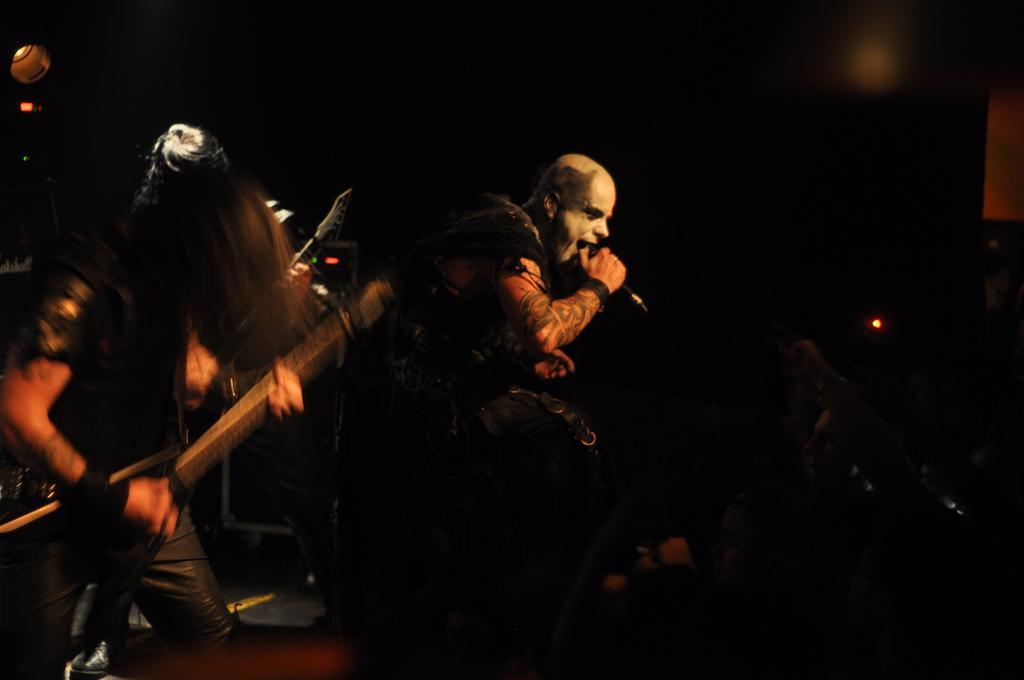Describe this image in one or two sentences. In the image we can see two persons. In the center we can see the man sitting on the chair and holding microphone. On the left side we can see one person holding guitar. And coming to back we can see light. 